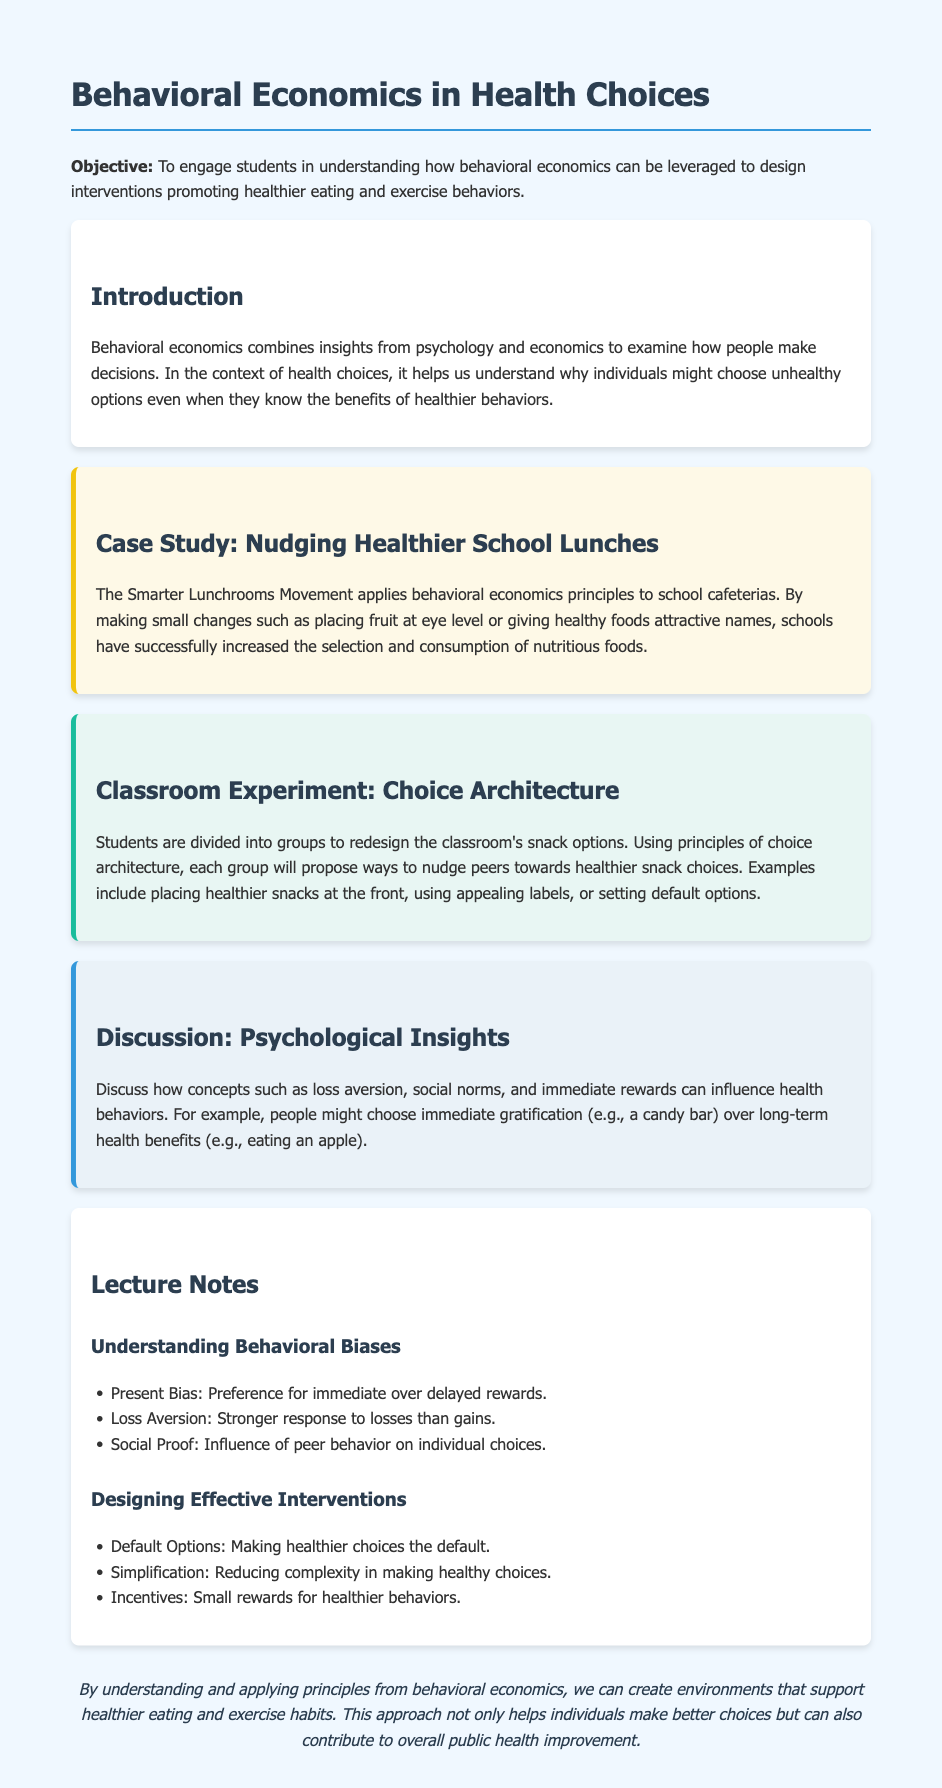What is the main objective of the lesson plan? The objective is to engage students in understanding how behavioral economics can be leveraged to design interventions promoting healthier eating and exercise behaviors.
Answer: To engage students in understanding how behavioral economics can be leveraged to design interventions promoting healthier eating and exercise behaviors Which movement is used as a case study? The case study refers to a specific initiative in schools that utilizes behavioral economics principles to improve lunch choices.
Answer: The Smarter Lunchrooms Movement What principle does the classroom experiment focus on? The classroom experiment emphasizes a strategy in behavioral economics aimed at influencing choices through environmental design.
Answer: Choice Architecture Name one psychological insight discussed in the document. This refers to a concept that explains how people's decisions may be influenced by cognitive biases.
Answer: Loss Aversion What is one method mentioned for designing effective interventions? This involves presenting a choice that can influence people's decision-making toward healthier options.
Answer: Default Options What is an example of immediate gratification discussed? This term refers to appealing choices that provide instant satisfaction, often at the expense of long-term benefits.
Answer: Candy bar According to the lecture notes, what bias refers to the preference for immediate over delayed rewards? This is a specific behavioral phenomenon indicating a tendency in human decision-making.
Answer: Present Bias What type of rewards are mentioned as an incentive for healthier behaviors? This refers to any form of compensation or benefit provided to encourage better health-related choices.
Answer: Small rewards 